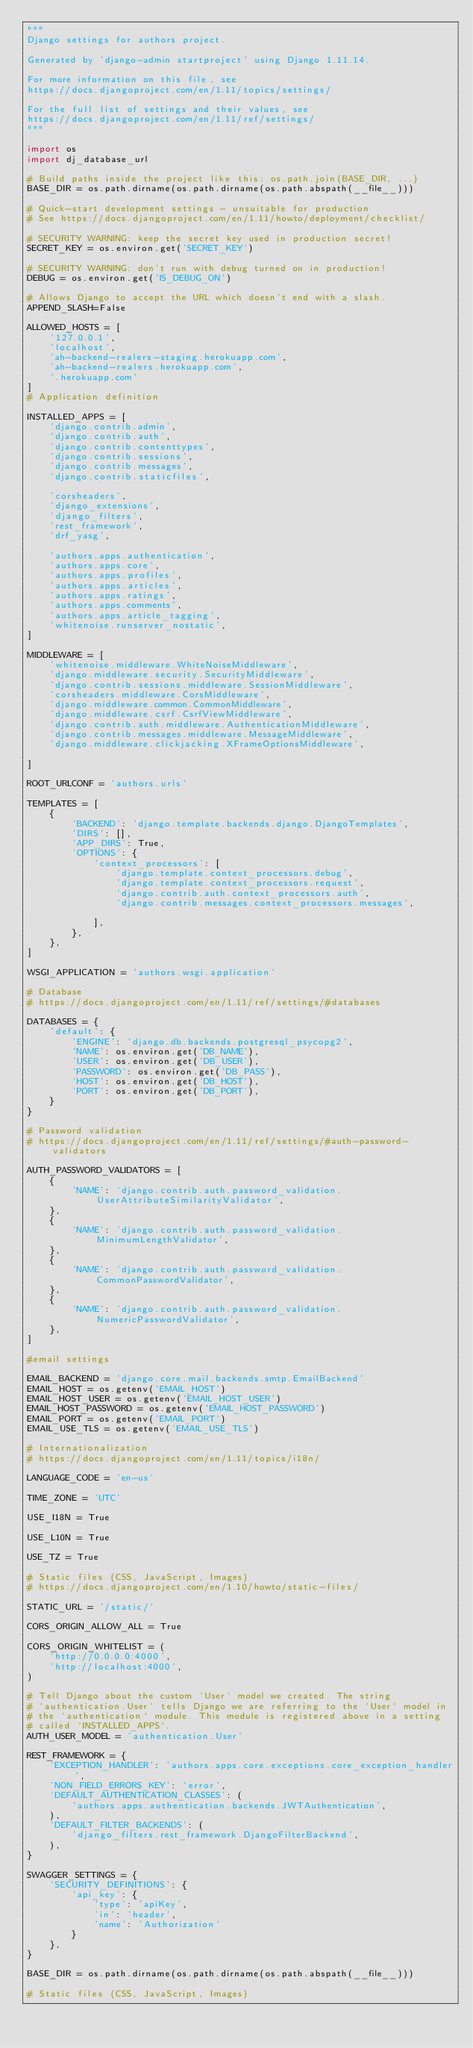<code> <loc_0><loc_0><loc_500><loc_500><_Python_>"""
Django settings for authors project.

Generated by 'django-admin startproject' using Django 1.11.14.

For more information on this file, see
https://docs.djangoproject.com/en/1.11/topics/settings/

For the full list of settings and their values, see
https://docs.djangoproject.com/en/1.11/ref/settings/
"""

import os
import dj_database_url 

# Build paths inside the project like this: os.path.join(BASE_DIR, ...)
BASE_DIR = os.path.dirname(os.path.dirname(os.path.abspath(__file__)))

# Quick-start development settings - unsuitable for production
# See https://docs.djangoproject.com/en/1.11/howto/deployment/checklist/

# SECURITY WARNING: keep the secret key used in production secret!
SECRET_KEY = os.environ.get('SECRET_KEY') 

# SECURITY WARNING: don't run with debug turned on in production!
DEBUG = os.environ.get('IS_DEBUG_ON')

# Allows Django to accept the URL which doesn't end with a slash.
APPEND_SLASH=False

ALLOWED_HOSTS = [
    '127.0.0.1', 
    'localhost',
    'ah-backend-realers-staging.herokuapp.com',
    'ah-backend-realers.herokuapp.com',
    '.herokuapp.com'
]
# Application definition

INSTALLED_APPS = [
    'django.contrib.admin',
    'django.contrib.auth',
    'django.contrib.contenttypes',
    'django.contrib.sessions',
    'django.contrib.messages',
    'django.contrib.staticfiles',

    'corsheaders',
    'django_extensions',
    'django_filters',
    'rest_framework',
    'drf_yasg',

    'authors.apps.authentication',
    'authors.apps.core',
    'authors.apps.profiles',
    'authors.apps.articles',
    'authors.apps.ratings',
    'authors.apps.comments',
    'authors.apps.article_tagging',
    'whitenoise.runserver_nostatic',
]

MIDDLEWARE = [
    'whitenoise.middleware.WhiteNoiseMiddleware',
    'django.middleware.security.SecurityMiddleware',
    'django.contrib.sessions.middleware.SessionMiddleware',
    'corsheaders.middleware.CorsMiddleware',
    'django.middleware.common.CommonMiddleware',
    'django.middleware.csrf.CsrfViewMiddleware',
    'django.contrib.auth.middleware.AuthenticationMiddleware',
    'django.contrib.messages.middleware.MessageMiddleware',
    'django.middleware.clickjacking.XFrameOptionsMiddleware',

]

ROOT_URLCONF = 'authors.urls'

TEMPLATES = [
    {
        'BACKEND': 'django.template.backends.django.DjangoTemplates',
        'DIRS': [],
        'APP_DIRS': True,
        'OPTIONS': {
            'context_processors': [
                'django.template.context_processors.debug',
                'django.template.context_processors.request',
                'django.contrib.auth.context_processors.auth',
                'django.contrib.messages.context_processors.messages',

            ],
        },
    },
]

WSGI_APPLICATION = 'authors.wsgi.application'

# Database
# https://docs.djangoproject.com/en/1.11/ref/settings/#databases

DATABASES = {
    'default': {
        'ENGINE': 'django.db.backends.postgresql_psycopg2',
        'NAME': os.environ.get('DB_NAME'),
        'USER': os.environ.get('DB_USER'),
        'PASSWORD': os.environ.get('DB_PASS'),
        'HOST': os.environ.get('DB_HOST'),
        'PORT': os.environ.get('DB_PORT'),
    }
}

# Password validation
# https://docs.djangoproject.com/en/1.11/ref/settings/#auth-password-validators

AUTH_PASSWORD_VALIDATORS = [
    {
        'NAME': 'django.contrib.auth.password_validation.UserAttributeSimilarityValidator',
    },
    {
        'NAME': 'django.contrib.auth.password_validation.MinimumLengthValidator',
    },
    {
        'NAME': 'django.contrib.auth.password_validation.CommonPasswordValidator',
    },
    {
        'NAME': 'django.contrib.auth.password_validation.NumericPasswordValidator',
    },
]

#email settings

EMAIL_BACKEND = 'django.core.mail.backends.smtp.EmailBackend'
EMAIL_HOST = os.getenv('EMAIL_HOST')
EMAIL_HOST_USER = os.getenv('EMAIL_HOST_USER')
EMAIL_HOST_PASSWORD = os.getenv('EMAIL_HOST_PASSWORD')
EMAIL_PORT = os.getenv('EMAIL_PORT')
EMAIL_USE_TLS = os.getenv('EMAIL_USE_TLS')

# Internationalization
# https://docs.djangoproject.com/en/1.11/topics/i18n/

LANGUAGE_CODE = 'en-us'

TIME_ZONE = 'UTC'

USE_I18N = True

USE_L10N = True

USE_TZ = True

# Static files (CSS, JavaScript, Images)
# https://docs.djangoproject.com/en/1.10/howto/static-files/

STATIC_URL = '/static/'

CORS_ORIGIN_ALLOW_ALL = True

CORS_ORIGIN_WHITELIST = (
    'http://0.0.0.0:4000',
    'http://localhost:4000',
)

# Tell Django about the custom `User` model we created. The string
# `authentication.User` tells Django we are referring to the `User` model in
# the `authentication` module. This module is registered above in a setting
# called `INSTALLED_APPS`.
AUTH_USER_MODEL = 'authentication.User'

REST_FRAMEWORK = {
    'EXCEPTION_HANDLER': 'authors.apps.core.exceptions.core_exception_handler',
    'NON_FIELD_ERRORS_KEY': 'error',
    'DEFAULT_AUTHENTICATION_CLASSES': (
        'authors.apps.authentication.backends.JWTAuthentication',
    ),
    'DEFAULT_FILTER_BACKENDS': (
        'django_filters.rest_framework.DjangoFilterBackend', 
    ),
}

SWAGGER_SETTINGS = {
    'SECURITY_DEFINITIONS': {
        'api_key': {
            'type': 'apiKey',
            'in': 'header',
            'name': 'Authorization'
        }
    },
}

BASE_DIR = os.path.dirname(os.path.dirname(os.path.abspath(__file__)))

# Static files (CSS, JavaScript, Images)</code> 